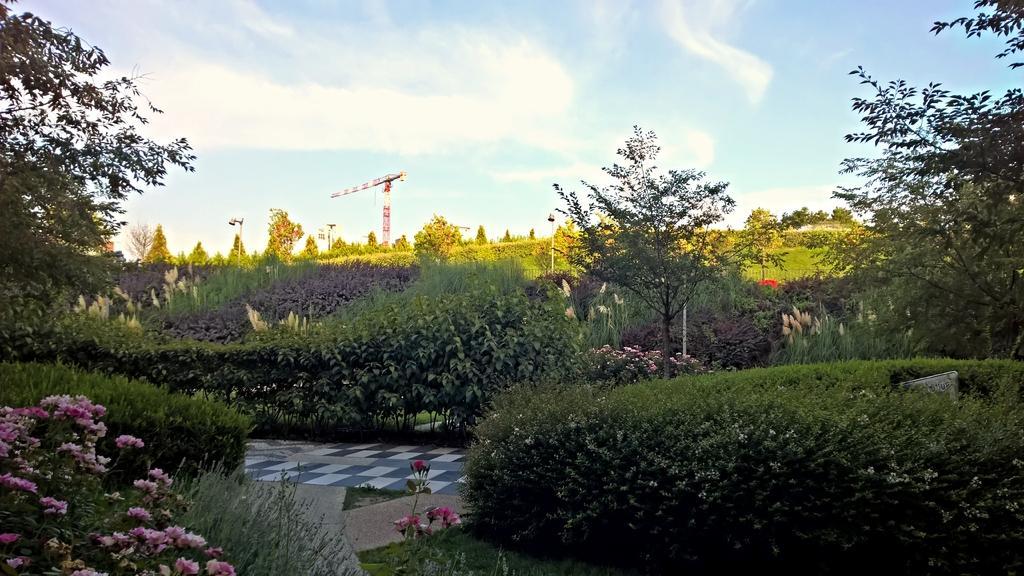Please provide a concise description of this image. In this image I can see many plants and trees. I can see some pink color flowers to the plants. In the back there is a pole, clouds and the blue sky. 